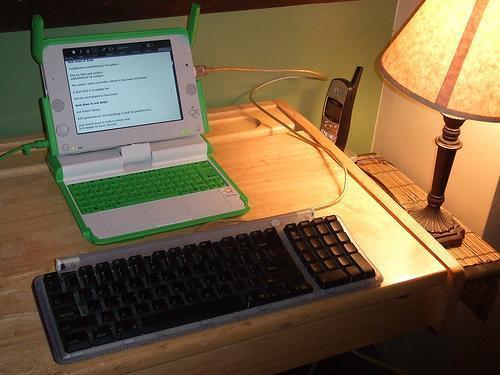How many keyboards are in the picture?
Give a very brief answer. 2. How many green keyboards are on the table?
Give a very brief answer. 1. 